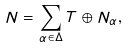<formula> <loc_0><loc_0><loc_500><loc_500>N = \sum _ { \alpha \in \Delta } T \oplus N _ { \alpha } ,</formula> 